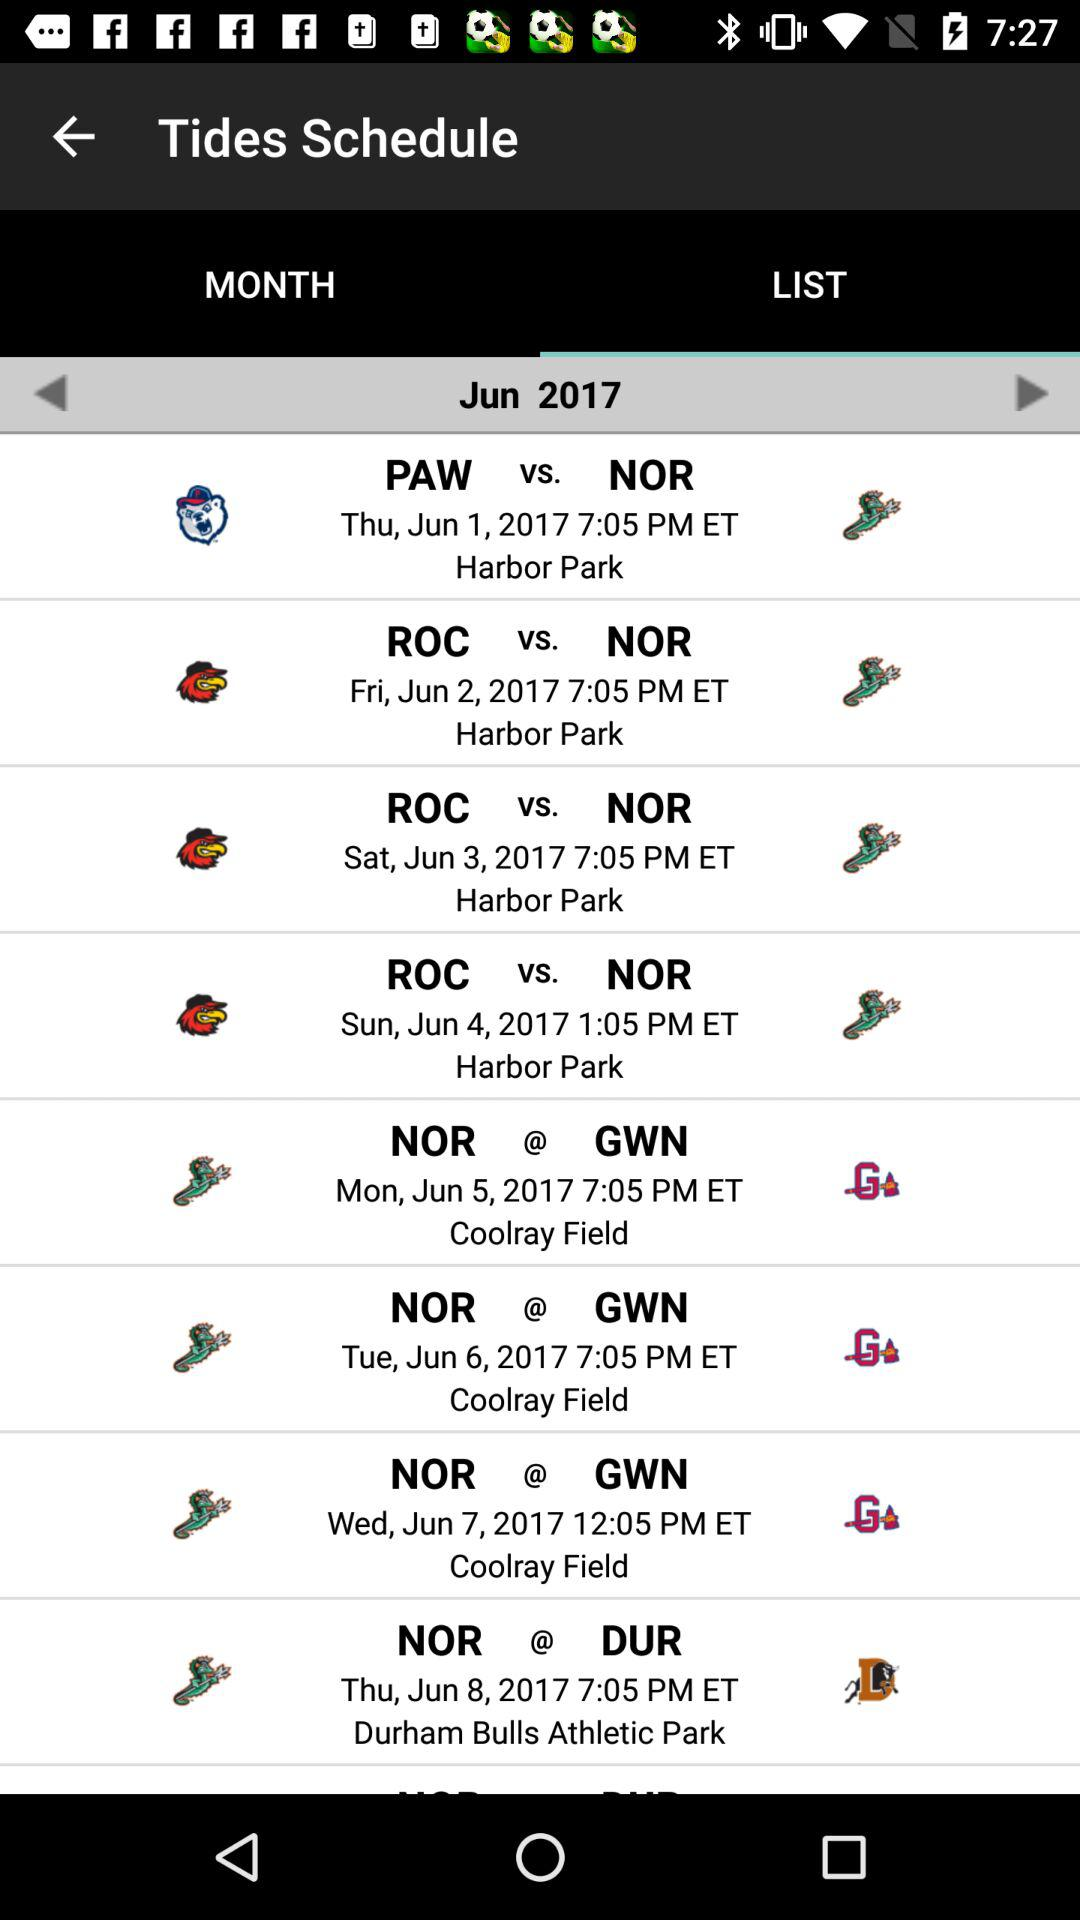On what date was the match played between the NOR and DUR teams? The match was played on June 8, 2017. 